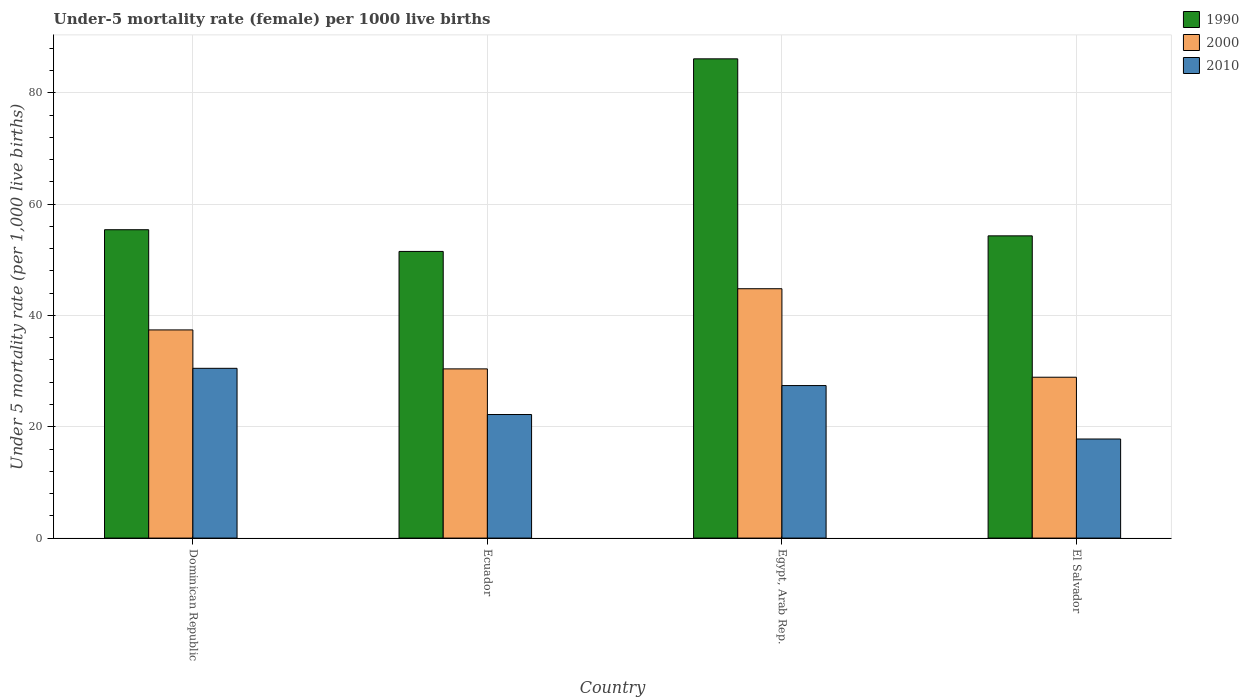How many different coloured bars are there?
Your response must be concise. 3. Are the number of bars per tick equal to the number of legend labels?
Offer a terse response. Yes. What is the label of the 4th group of bars from the left?
Ensure brevity in your answer.  El Salvador. In how many cases, is the number of bars for a given country not equal to the number of legend labels?
Keep it short and to the point. 0. What is the under-five mortality rate in 2000 in Egypt, Arab Rep.?
Offer a terse response. 44.8. Across all countries, what is the maximum under-five mortality rate in 1990?
Make the answer very short. 86.1. Across all countries, what is the minimum under-five mortality rate in 1990?
Your answer should be very brief. 51.5. In which country was the under-five mortality rate in 2000 maximum?
Your answer should be compact. Egypt, Arab Rep. In which country was the under-five mortality rate in 2010 minimum?
Your answer should be compact. El Salvador. What is the total under-five mortality rate in 2010 in the graph?
Ensure brevity in your answer.  97.9. What is the difference between the under-five mortality rate in 1990 in Dominican Republic and that in Ecuador?
Offer a very short reply. 3.9. What is the difference between the under-five mortality rate in 1990 in El Salvador and the under-five mortality rate in 2000 in Ecuador?
Provide a succinct answer. 23.9. What is the average under-five mortality rate in 2010 per country?
Provide a short and direct response. 24.47. What is the difference between the under-five mortality rate of/in 2000 and under-five mortality rate of/in 2010 in El Salvador?
Offer a terse response. 11.1. In how many countries, is the under-five mortality rate in 2000 greater than 36?
Provide a short and direct response. 2. What is the ratio of the under-five mortality rate in 2000 in Egypt, Arab Rep. to that in El Salvador?
Offer a terse response. 1.55. Is the difference between the under-five mortality rate in 2000 in Ecuador and Egypt, Arab Rep. greater than the difference between the under-five mortality rate in 2010 in Ecuador and Egypt, Arab Rep.?
Make the answer very short. No. What is the difference between the highest and the second highest under-five mortality rate in 1990?
Offer a terse response. -31.8. What is the difference between the highest and the lowest under-five mortality rate in 1990?
Your response must be concise. 34.6. In how many countries, is the under-five mortality rate in 1990 greater than the average under-five mortality rate in 1990 taken over all countries?
Offer a very short reply. 1. Is it the case that in every country, the sum of the under-five mortality rate in 2010 and under-five mortality rate in 1990 is greater than the under-five mortality rate in 2000?
Keep it short and to the point. Yes. How many bars are there?
Your response must be concise. 12. Are all the bars in the graph horizontal?
Give a very brief answer. No. Does the graph contain grids?
Make the answer very short. Yes. How many legend labels are there?
Provide a short and direct response. 3. What is the title of the graph?
Keep it short and to the point. Under-5 mortality rate (female) per 1000 live births. What is the label or title of the X-axis?
Your answer should be very brief. Country. What is the label or title of the Y-axis?
Keep it short and to the point. Under 5 mortality rate (per 1,0 live births). What is the Under 5 mortality rate (per 1,000 live births) of 1990 in Dominican Republic?
Give a very brief answer. 55.4. What is the Under 5 mortality rate (per 1,000 live births) in 2000 in Dominican Republic?
Provide a succinct answer. 37.4. What is the Under 5 mortality rate (per 1,000 live births) in 2010 in Dominican Republic?
Offer a terse response. 30.5. What is the Under 5 mortality rate (per 1,000 live births) of 1990 in Ecuador?
Give a very brief answer. 51.5. What is the Under 5 mortality rate (per 1,000 live births) in 2000 in Ecuador?
Ensure brevity in your answer.  30.4. What is the Under 5 mortality rate (per 1,000 live births) in 2010 in Ecuador?
Your answer should be compact. 22.2. What is the Under 5 mortality rate (per 1,000 live births) in 1990 in Egypt, Arab Rep.?
Provide a short and direct response. 86.1. What is the Under 5 mortality rate (per 1,000 live births) of 2000 in Egypt, Arab Rep.?
Offer a very short reply. 44.8. What is the Under 5 mortality rate (per 1,000 live births) in 2010 in Egypt, Arab Rep.?
Provide a succinct answer. 27.4. What is the Under 5 mortality rate (per 1,000 live births) of 1990 in El Salvador?
Offer a very short reply. 54.3. What is the Under 5 mortality rate (per 1,000 live births) of 2000 in El Salvador?
Offer a very short reply. 28.9. What is the Under 5 mortality rate (per 1,000 live births) in 2010 in El Salvador?
Ensure brevity in your answer.  17.8. Across all countries, what is the maximum Under 5 mortality rate (per 1,000 live births) of 1990?
Provide a succinct answer. 86.1. Across all countries, what is the maximum Under 5 mortality rate (per 1,000 live births) of 2000?
Provide a succinct answer. 44.8. Across all countries, what is the maximum Under 5 mortality rate (per 1,000 live births) of 2010?
Your answer should be very brief. 30.5. Across all countries, what is the minimum Under 5 mortality rate (per 1,000 live births) of 1990?
Give a very brief answer. 51.5. Across all countries, what is the minimum Under 5 mortality rate (per 1,000 live births) of 2000?
Provide a succinct answer. 28.9. Across all countries, what is the minimum Under 5 mortality rate (per 1,000 live births) in 2010?
Provide a short and direct response. 17.8. What is the total Under 5 mortality rate (per 1,000 live births) in 1990 in the graph?
Provide a short and direct response. 247.3. What is the total Under 5 mortality rate (per 1,000 live births) of 2000 in the graph?
Your response must be concise. 141.5. What is the total Under 5 mortality rate (per 1,000 live births) of 2010 in the graph?
Your answer should be very brief. 97.9. What is the difference between the Under 5 mortality rate (per 1,000 live births) in 2000 in Dominican Republic and that in Ecuador?
Provide a short and direct response. 7. What is the difference between the Under 5 mortality rate (per 1,000 live births) in 1990 in Dominican Republic and that in Egypt, Arab Rep.?
Offer a very short reply. -30.7. What is the difference between the Under 5 mortality rate (per 1,000 live births) in 2000 in Dominican Republic and that in Egypt, Arab Rep.?
Your answer should be compact. -7.4. What is the difference between the Under 5 mortality rate (per 1,000 live births) of 2010 in Dominican Republic and that in Egypt, Arab Rep.?
Give a very brief answer. 3.1. What is the difference between the Under 5 mortality rate (per 1,000 live births) in 1990 in Dominican Republic and that in El Salvador?
Your answer should be compact. 1.1. What is the difference between the Under 5 mortality rate (per 1,000 live births) of 2000 in Dominican Republic and that in El Salvador?
Keep it short and to the point. 8.5. What is the difference between the Under 5 mortality rate (per 1,000 live births) in 2010 in Dominican Republic and that in El Salvador?
Ensure brevity in your answer.  12.7. What is the difference between the Under 5 mortality rate (per 1,000 live births) in 1990 in Ecuador and that in Egypt, Arab Rep.?
Keep it short and to the point. -34.6. What is the difference between the Under 5 mortality rate (per 1,000 live births) of 2000 in Ecuador and that in Egypt, Arab Rep.?
Ensure brevity in your answer.  -14.4. What is the difference between the Under 5 mortality rate (per 1,000 live births) of 2010 in Ecuador and that in Egypt, Arab Rep.?
Keep it short and to the point. -5.2. What is the difference between the Under 5 mortality rate (per 1,000 live births) in 1990 in Ecuador and that in El Salvador?
Your answer should be compact. -2.8. What is the difference between the Under 5 mortality rate (per 1,000 live births) of 1990 in Egypt, Arab Rep. and that in El Salvador?
Your response must be concise. 31.8. What is the difference between the Under 5 mortality rate (per 1,000 live births) of 2000 in Egypt, Arab Rep. and that in El Salvador?
Offer a very short reply. 15.9. What is the difference between the Under 5 mortality rate (per 1,000 live births) of 2010 in Egypt, Arab Rep. and that in El Salvador?
Offer a terse response. 9.6. What is the difference between the Under 5 mortality rate (per 1,000 live births) in 1990 in Dominican Republic and the Under 5 mortality rate (per 1,000 live births) in 2000 in Ecuador?
Offer a very short reply. 25. What is the difference between the Under 5 mortality rate (per 1,000 live births) in 1990 in Dominican Republic and the Under 5 mortality rate (per 1,000 live births) in 2010 in Ecuador?
Give a very brief answer. 33.2. What is the difference between the Under 5 mortality rate (per 1,000 live births) of 1990 in Dominican Republic and the Under 5 mortality rate (per 1,000 live births) of 2010 in Egypt, Arab Rep.?
Keep it short and to the point. 28. What is the difference between the Under 5 mortality rate (per 1,000 live births) of 2000 in Dominican Republic and the Under 5 mortality rate (per 1,000 live births) of 2010 in Egypt, Arab Rep.?
Give a very brief answer. 10. What is the difference between the Under 5 mortality rate (per 1,000 live births) of 1990 in Dominican Republic and the Under 5 mortality rate (per 1,000 live births) of 2000 in El Salvador?
Offer a very short reply. 26.5. What is the difference between the Under 5 mortality rate (per 1,000 live births) of 1990 in Dominican Republic and the Under 5 mortality rate (per 1,000 live births) of 2010 in El Salvador?
Your answer should be very brief. 37.6. What is the difference between the Under 5 mortality rate (per 1,000 live births) in 2000 in Dominican Republic and the Under 5 mortality rate (per 1,000 live births) in 2010 in El Salvador?
Ensure brevity in your answer.  19.6. What is the difference between the Under 5 mortality rate (per 1,000 live births) in 1990 in Ecuador and the Under 5 mortality rate (per 1,000 live births) in 2010 in Egypt, Arab Rep.?
Keep it short and to the point. 24.1. What is the difference between the Under 5 mortality rate (per 1,000 live births) of 1990 in Ecuador and the Under 5 mortality rate (per 1,000 live births) of 2000 in El Salvador?
Ensure brevity in your answer.  22.6. What is the difference between the Under 5 mortality rate (per 1,000 live births) of 1990 in Ecuador and the Under 5 mortality rate (per 1,000 live births) of 2010 in El Salvador?
Make the answer very short. 33.7. What is the difference between the Under 5 mortality rate (per 1,000 live births) in 2000 in Ecuador and the Under 5 mortality rate (per 1,000 live births) in 2010 in El Salvador?
Ensure brevity in your answer.  12.6. What is the difference between the Under 5 mortality rate (per 1,000 live births) in 1990 in Egypt, Arab Rep. and the Under 5 mortality rate (per 1,000 live births) in 2000 in El Salvador?
Provide a succinct answer. 57.2. What is the difference between the Under 5 mortality rate (per 1,000 live births) of 1990 in Egypt, Arab Rep. and the Under 5 mortality rate (per 1,000 live births) of 2010 in El Salvador?
Ensure brevity in your answer.  68.3. What is the difference between the Under 5 mortality rate (per 1,000 live births) in 2000 in Egypt, Arab Rep. and the Under 5 mortality rate (per 1,000 live births) in 2010 in El Salvador?
Make the answer very short. 27. What is the average Under 5 mortality rate (per 1,000 live births) of 1990 per country?
Your answer should be very brief. 61.83. What is the average Under 5 mortality rate (per 1,000 live births) in 2000 per country?
Your answer should be compact. 35.38. What is the average Under 5 mortality rate (per 1,000 live births) of 2010 per country?
Your response must be concise. 24.48. What is the difference between the Under 5 mortality rate (per 1,000 live births) in 1990 and Under 5 mortality rate (per 1,000 live births) in 2010 in Dominican Republic?
Provide a short and direct response. 24.9. What is the difference between the Under 5 mortality rate (per 1,000 live births) of 1990 and Under 5 mortality rate (per 1,000 live births) of 2000 in Ecuador?
Provide a short and direct response. 21.1. What is the difference between the Under 5 mortality rate (per 1,000 live births) in 1990 and Under 5 mortality rate (per 1,000 live births) in 2010 in Ecuador?
Your response must be concise. 29.3. What is the difference between the Under 5 mortality rate (per 1,000 live births) in 2000 and Under 5 mortality rate (per 1,000 live births) in 2010 in Ecuador?
Give a very brief answer. 8.2. What is the difference between the Under 5 mortality rate (per 1,000 live births) in 1990 and Under 5 mortality rate (per 1,000 live births) in 2000 in Egypt, Arab Rep.?
Your answer should be very brief. 41.3. What is the difference between the Under 5 mortality rate (per 1,000 live births) in 1990 and Under 5 mortality rate (per 1,000 live births) in 2010 in Egypt, Arab Rep.?
Give a very brief answer. 58.7. What is the difference between the Under 5 mortality rate (per 1,000 live births) in 2000 and Under 5 mortality rate (per 1,000 live births) in 2010 in Egypt, Arab Rep.?
Provide a succinct answer. 17.4. What is the difference between the Under 5 mortality rate (per 1,000 live births) of 1990 and Under 5 mortality rate (per 1,000 live births) of 2000 in El Salvador?
Offer a terse response. 25.4. What is the difference between the Under 5 mortality rate (per 1,000 live births) of 1990 and Under 5 mortality rate (per 1,000 live births) of 2010 in El Salvador?
Provide a succinct answer. 36.5. What is the difference between the Under 5 mortality rate (per 1,000 live births) in 2000 and Under 5 mortality rate (per 1,000 live births) in 2010 in El Salvador?
Provide a succinct answer. 11.1. What is the ratio of the Under 5 mortality rate (per 1,000 live births) in 1990 in Dominican Republic to that in Ecuador?
Offer a terse response. 1.08. What is the ratio of the Under 5 mortality rate (per 1,000 live births) of 2000 in Dominican Republic to that in Ecuador?
Provide a succinct answer. 1.23. What is the ratio of the Under 5 mortality rate (per 1,000 live births) in 2010 in Dominican Republic to that in Ecuador?
Ensure brevity in your answer.  1.37. What is the ratio of the Under 5 mortality rate (per 1,000 live births) in 1990 in Dominican Republic to that in Egypt, Arab Rep.?
Your answer should be very brief. 0.64. What is the ratio of the Under 5 mortality rate (per 1,000 live births) in 2000 in Dominican Republic to that in Egypt, Arab Rep.?
Offer a very short reply. 0.83. What is the ratio of the Under 5 mortality rate (per 1,000 live births) of 2010 in Dominican Republic to that in Egypt, Arab Rep.?
Offer a very short reply. 1.11. What is the ratio of the Under 5 mortality rate (per 1,000 live births) in 1990 in Dominican Republic to that in El Salvador?
Keep it short and to the point. 1.02. What is the ratio of the Under 5 mortality rate (per 1,000 live births) in 2000 in Dominican Republic to that in El Salvador?
Your answer should be very brief. 1.29. What is the ratio of the Under 5 mortality rate (per 1,000 live births) of 2010 in Dominican Republic to that in El Salvador?
Your response must be concise. 1.71. What is the ratio of the Under 5 mortality rate (per 1,000 live births) in 1990 in Ecuador to that in Egypt, Arab Rep.?
Keep it short and to the point. 0.6. What is the ratio of the Under 5 mortality rate (per 1,000 live births) of 2000 in Ecuador to that in Egypt, Arab Rep.?
Keep it short and to the point. 0.68. What is the ratio of the Under 5 mortality rate (per 1,000 live births) in 2010 in Ecuador to that in Egypt, Arab Rep.?
Make the answer very short. 0.81. What is the ratio of the Under 5 mortality rate (per 1,000 live births) in 1990 in Ecuador to that in El Salvador?
Make the answer very short. 0.95. What is the ratio of the Under 5 mortality rate (per 1,000 live births) in 2000 in Ecuador to that in El Salvador?
Give a very brief answer. 1.05. What is the ratio of the Under 5 mortality rate (per 1,000 live births) of 2010 in Ecuador to that in El Salvador?
Your answer should be compact. 1.25. What is the ratio of the Under 5 mortality rate (per 1,000 live births) in 1990 in Egypt, Arab Rep. to that in El Salvador?
Provide a short and direct response. 1.59. What is the ratio of the Under 5 mortality rate (per 1,000 live births) in 2000 in Egypt, Arab Rep. to that in El Salvador?
Keep it short and to the point. 1.55. What is the ratio of the Under 5 mortality rate (per 1,000 live births) in 2010 in Egypt, Arab Rep. to that in El Salvador?
Provide a succinct answer. 1.54. What is the difference between the highest and the second highest Under 5 mortality rate (per 1,000 live births) in 1990?
Offer a very short reply. 30.7. What is the difference between the highest and the second highest Under 5 mortality rate (per 1,000 live births) of 2000?
Offer a very short reply. 7.4. What is the difference between the highest and the second highest Under 5 mortality rate (per 1,000 live births) in 2010?
Keep it short and to the point. 3.1. What is the difference between the highest and the lowest Under 5 mortality rate (per 1,000 live births) in 1990?
Your answer should be very brief. 34.6. What is the difference between the highest and the lowest Under 5 mortality rate (per 1,000 live births) in 2010?
Ensure brevity in your answer.  12.7. 